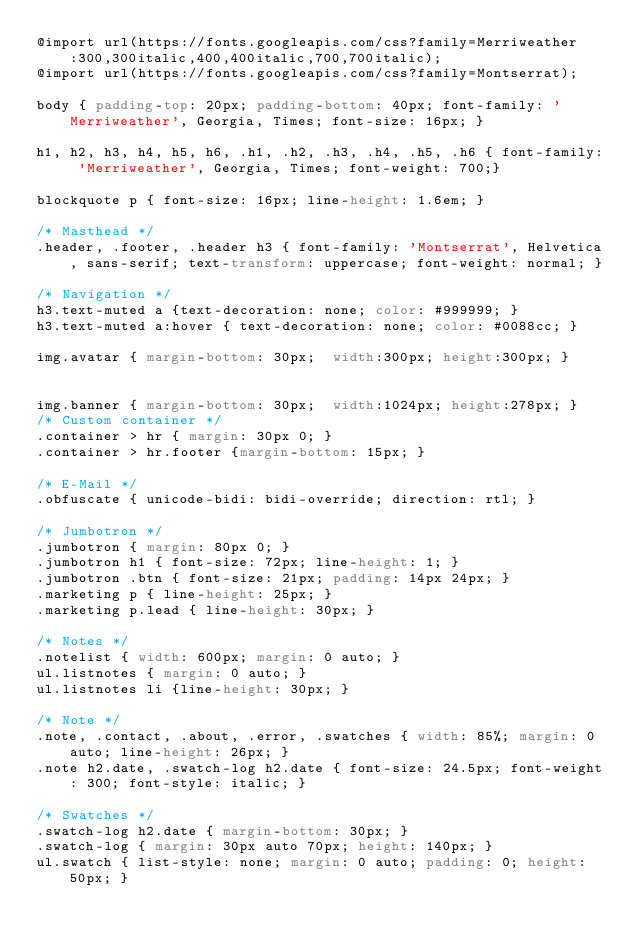Convert code to text. <code><loc_0><loc_0><loc_500><loc_500><_CSS_>@import url(https://fonts.googleapis.com/css?family=Merriweather:300,300italic,400,400italic,700,700italic);
@import url(https://fonts.googleapis.com/css?family=Montserrat);

body { padding-top: 20px; padding-bottom: 40px; font-family: 'Merriweather', Georgia, Times; font-size: 16px; }

h1, h2, h3, h4, h5, h6, .h1, .h2, .h3, .h4, .h5, .h6 { font-family: 'Merriweather', Georgia, Times; font-weight: 700;}

blockquote p { font-size: 16px; line-height: 1.6em; }

/* Masthead */
.header, .footer, .header h3 { font-family: 'Montserrat', Helvetica, sans-serif; text-transform: uppercase; font-weight: normal; }

/* Navigation */
h3.text-muted a {text-decoration: none; color: #999999; }
h3.text-muted a:hover { text-decoration: none; color: #0088cc; }

img.avatar { margin-bottom: 30px;  width:300px; height:300px; }


img.banner { margin-bottom: 30px;  width:1024px; height:278px; }
/* Custom container */
.container > hr { margin: 30px 0; }
.container > hr.footer {margin-bottom: 15px; }

/* E-Mail */
.obfuscate { unicode-bidi: bidi-override; direction: rtl; }

/* Jumbotron */     
.jumbotron { margin: 80px 0; }
.jumbotron h1 { font-size: 72px; line-height: 1; }
.jumbotron .btn { font-size: 21px; padding: 14px 24px; }
.marketing p { line-height: 25px; }
.marketing p.lead { line-height: 30px; }

/* Notes */
.notelist { width: 600px; margin: 0 auto; }
ul.listnotes { margin: 0 auto; }
ul.listnotes li {line-height: 30px; } 

/* Note */
.note, .contact, .about, .error, .swatches { width: 85%; margin: 0 auto; line-height: 26px; }
.note h2.date, .swatch-log h2.date { font-size: 24.5px; font-weight: 300; font-style: italic; }

/* Swatches */
.swatch-log h2.date { margin-bottom: 30px; }
.swatch-log { margin: 30px auto 70px; height: 140px; }
ul.swatch { list-style: none; margin: 0 auto; padding: 0; height: 50px; }</code> 